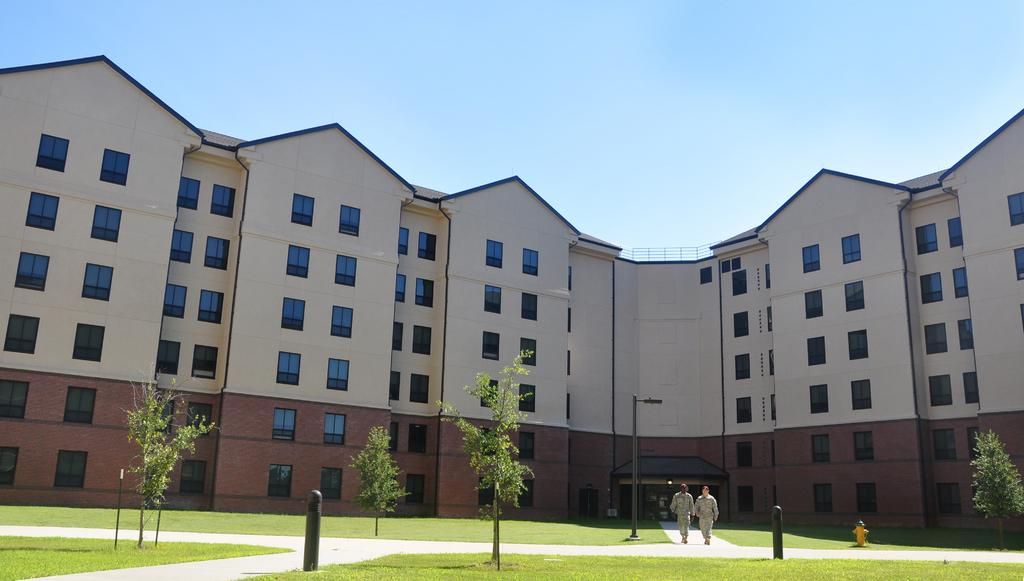What type of structures can be seen in the image? There are buildings in the image. What type of vegetation is present in the image? There are trees and grass in the image. What are the two persons in the image doing? Two persons are walking on a path in the image. What type of beginner's instrument can be seen in the hands of the two persons walking on the path? There is no instrument present in the image, and the two persons are not holding anything. What type of rhythm can be heard in the image? There is no sound or music present in the image, so it is not possible to determine any rhythm. 